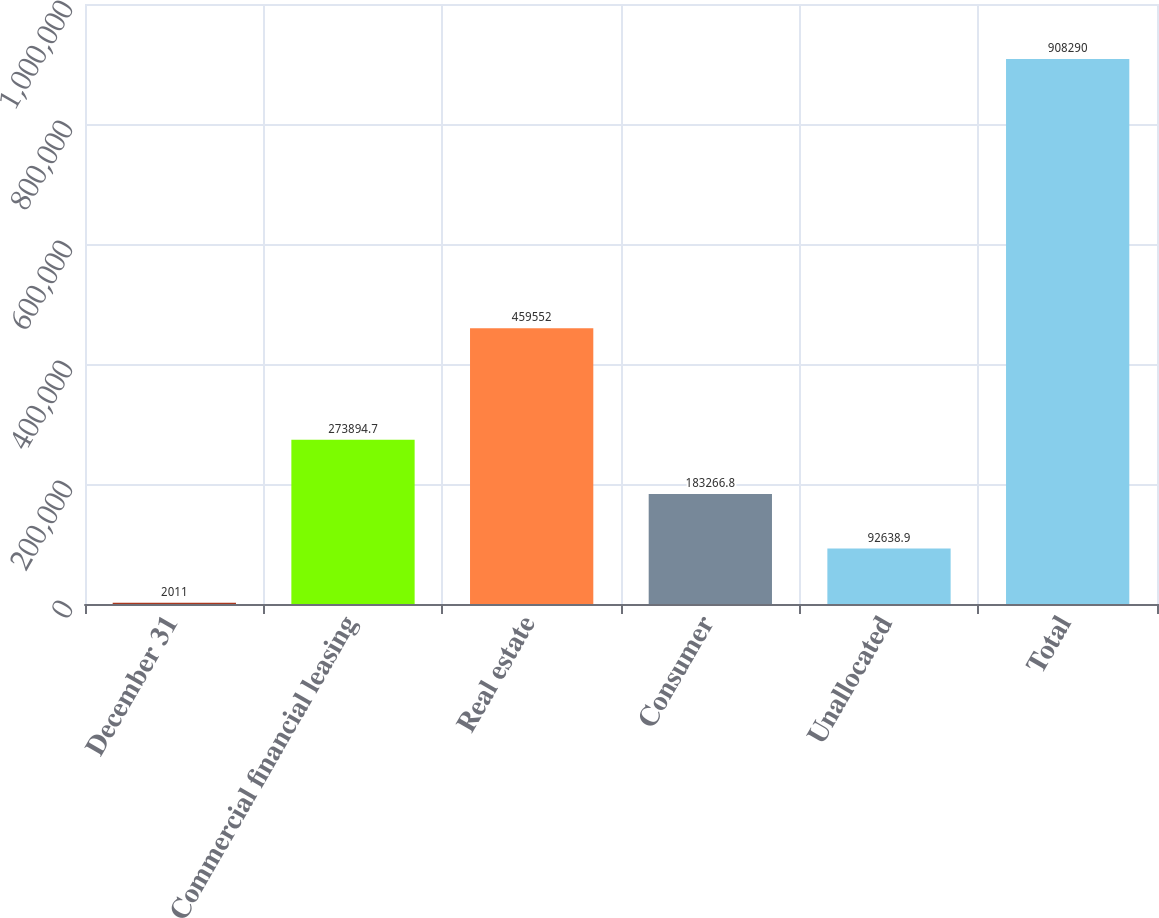Convert chart to OTSL. <chart><loc_0><loc_0><loc_500><loc_500><bar_chart><fcel>December 31<fcel>Commercial financial leasing<fcel>Real estate<fcel>Consumer<fcel>Unallocated<fcel>Total<nl><fcel>2011<fcel>273895<fcel>459552<fcel>183267<fcel>92638.9<fcel>908290<nl></chart> 